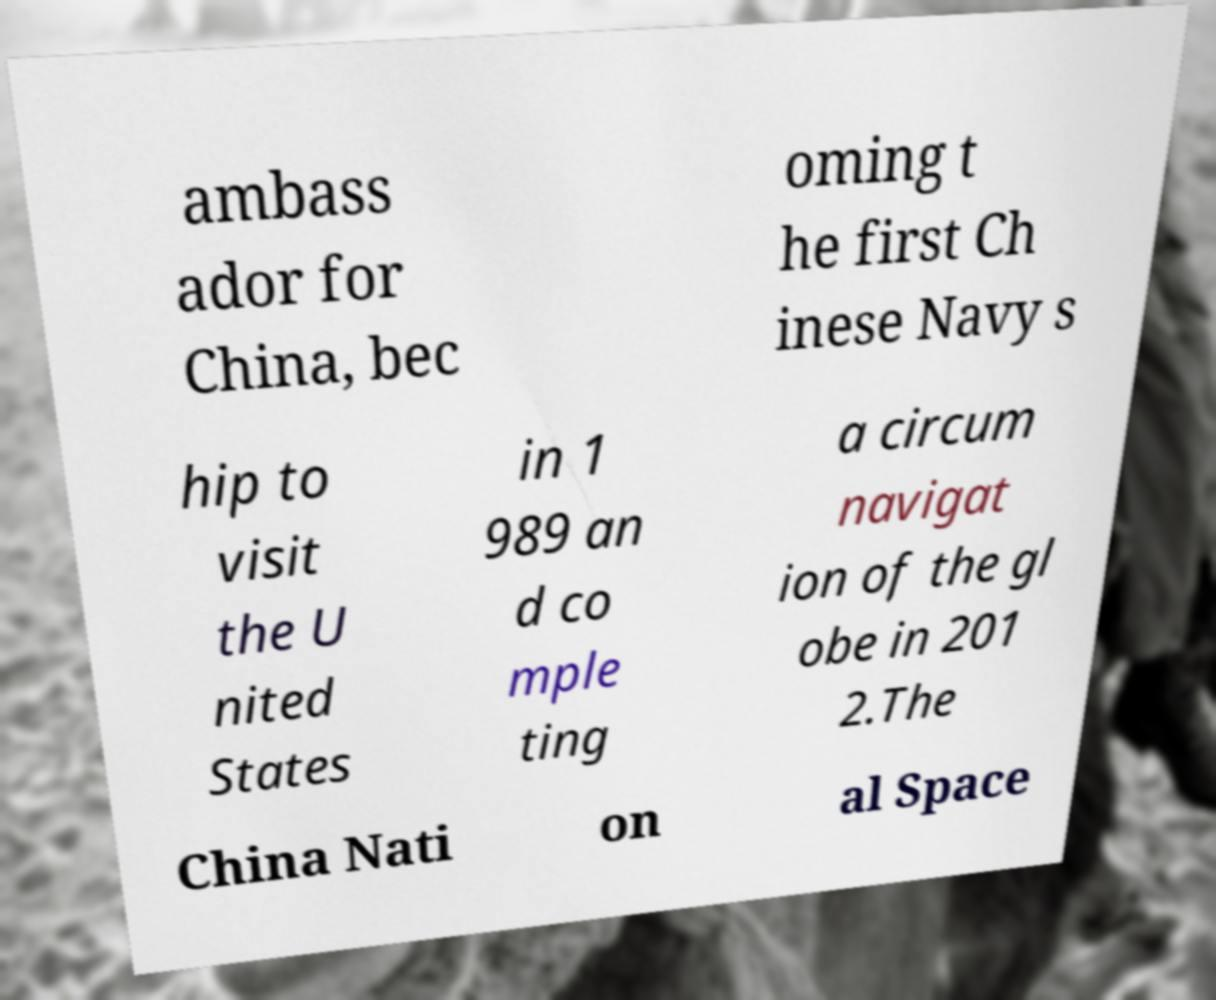Please identify and transcribe the text found in this image. ambass ador for China, bec oming t he first Ch inese Navy s hip to visit the U nited States in 1 989 an d co mple ting a circum navigat ion of the gl obe in 201 2.The China Nati on al Space 